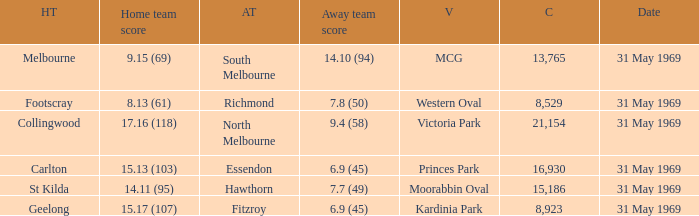In the game where the home team scored 15.17 (107), who was the away team? Fitzroy. 